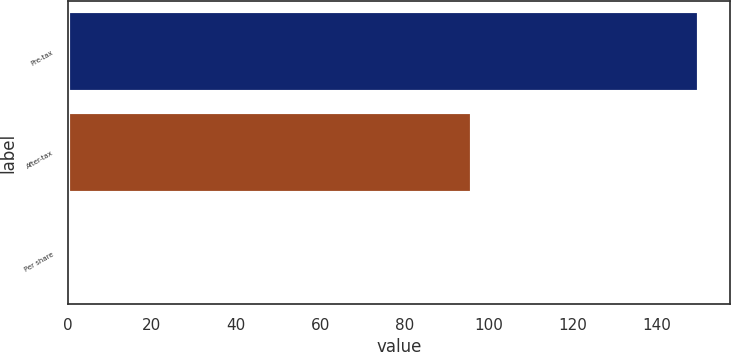<chart> <loc_0><loc_0><loc_500><loc_500><bar_chart><fcel>Pre-tax<fcel>After-tax<fcel>Per share<nl><fcel>150<fcel>96<fcel>0.06<nl></chart> 